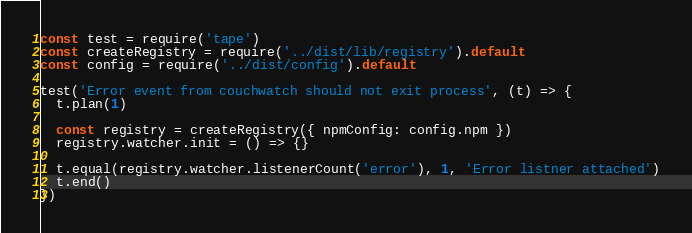Convert code to text. <code><loc_0><loc_0><loc_500><loc_500><_JavaScript_>const test = require('tape')
const createRegistry = require('../dist/lib/registry').default
const config = require('../dist/config').default

test('Error event from couchwatch should not exit process', (t) => {
  t.plan(1)

  const registry = createRegistry({ npmConfig: config.npm })
  registry.watcher.init = () => {}

  t.equal(registry.watcher.listenerCount('error'), 1, 'Error listner attached')
  t.end()
})
</code> 